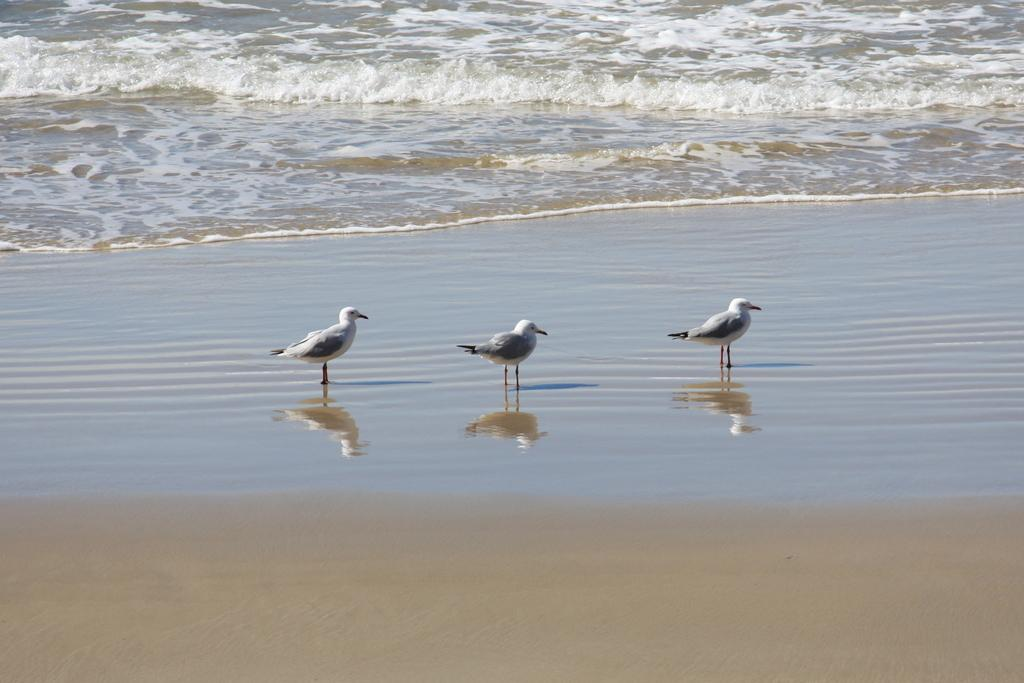What type of environment is shown in the image? The image depicts a sea. What animals can be seen in the image? There are birds standing in the image. What is the primary substance visible in the image? There is water visible in the image. What is at the bottom of the image? There is sand at the bottom of the image. What can be observed on the water's surface in the image? There is a reflection of birds on the water. What type of disease is affecting the birds in the image? There is no indication of any disease affecting the birds in the image. How many nails can be seen in the image? There are no nails present in the image. 